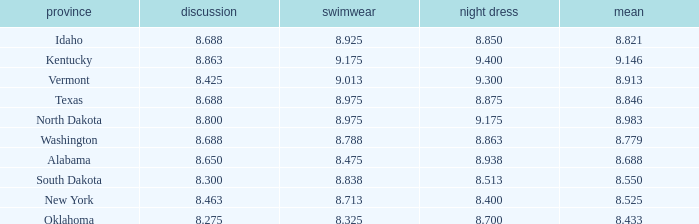What is the highest average of the contestant from Texas with an evening gown larger than 8.875? None. 